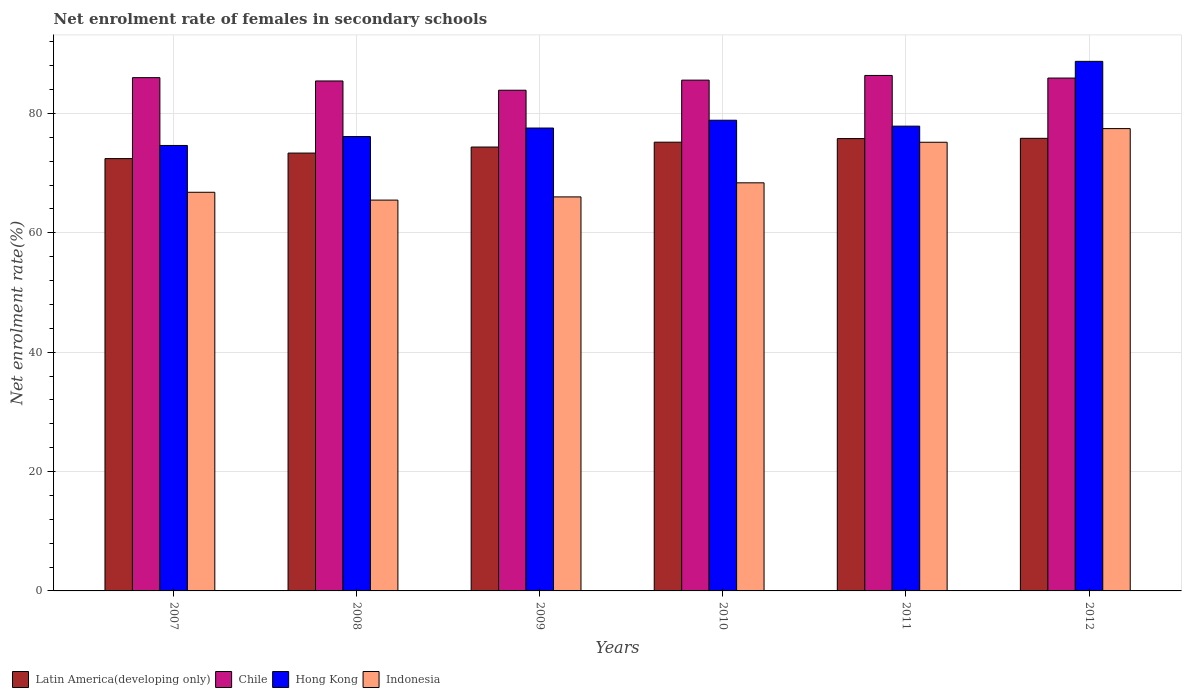How many different coloured bars are there?
Offer a very short reply. 4. Are the number of bars per tick equal to the number of legend labels?
Provide a succinct answer. Yes. How many bars are there on the 5th tick from the right?
Offer a very short reply. 4. What is the label of the 6th group of bars from the left?
Keep it short and to the point. 2012. In how many cases, is the number of bars for a given year not equal to the number of legend labels?
Offer a very short reply. 0. What is the net enrolment rate of females in secondary schools in Indonesia in 2012?
Your response must be concise. 77.46. Across all years, what is the maximum net enrolment rate of females in secondary schools in Hong Kong?
Your answer should be compact. 88.73. Across all years, what is the minimum net enrolment rate of females in secondary schools in Indonesia?
Ensure brevity in your answer.  65.48. In which year was the net enrolment rate of females in secondary schools in Chile maximum?
Keep it short and to the point. 2011. What is the total net enrolment rate of females in secondary schools in Latin America(developing only) in the graph?
Provide a succinct answer. 446.98. What is the difference between the net enrolment rate of females in secondary schools in Chile in 2007 and that in 2009?
Your response must be concise. 2.11. What is the difference between the net enrolment rate of females in secondary schools in Hong Kong in 2008 and the net enrolment rate of females in secondary schools in Latin America(developing only) in 2012?
Provide a succinct answer. 0.3. What is the average net enrolment rate of females in secondary schools in Indonesia per year?
Offer a terse response. 69.88. In the year 2012, what is the difference between the net enrolment rate of females in secondary schools in Latin America(developing only) and net enrolment rate of females in secondary schools in Chile?
Your answer should be compact. -10.1. In how many years, is the net enrolment rate of females in secondary schools in Hong Kong greater than 64 %?
Provide a succinct answer. 6. What is the ratio of the net enrolment rate of females in secondary schools in Chile in 2007 to that in 2012?
Your answer should be compact. 1. Is the net enrolment rate of females in secondary schools in Chile in 2007 less than that in 2008?
Ensure brevity in your answer.  No. Is the difference between the net enrolment rate of females in secondary schools in Latin America(developing only) in 2008 and 2010 greater than the difference between the net enrolment rate of females in secondary schools in Chile in 2008 and 2010?
Your response must be concise. No. What is the difference between the highest and the second highest net enrolment rate of females in secondary schools in Hong Kong?
Offer a terse response. 9.86. What is the difference between the highest and the lowest net enrolment rate of females in secondary schools in Indonesia?
Your response must be concise. 11.98. In how many years, is the net enrolment rate of females in secondary schools in Latin America(developing only) greater than the average net enrolment rate of females in secondary schools in Latin America(developing only) taken over all years?
Offer a terse response. 3. Is it the case that in every year, the sum of the net enrolment rate of females in secondary schools in Chile and net enrolment rate of females in secondary schools in Latin America(developing only) is greater than the sum of net enrolment rate of females in secondary schools in Indonesia and net enrolment rate of females in secondary schools in Hong Kong?
Offer a terse response. No. What does the 1st bar from the left in 2007 represents?
Your response must be concise. Latin America(developing only). What does the 3rd bar from the right in 2012 represents?
Provide a succinct answer. Chile. Is it the case that in every year, the sum of the net enrolment rate of females in secondary schools in Hong Kong and net enrolment rate of females in secondary schools in Indonesia is greater than the net enrolment rate of females in secondary schools in Latin America(developing only)?
Your answer should be very brief. Yes. What is the difference between two consecutive major ticks on the Y-axis?
Ensure brevity in your answer.  20. Where does the legend appear in the graph?
Your answer should be compact. Bottom left. How are the legend labels stacked?
Give a very brief answer. Horizontal. What is the title of the graph?
Give a very brief answer. Net enrolment rate of females in secondary schools. What is the label or title of the X-axis?
Your answer should be compact. Years. What is the label or title of the Y-axis?
Your answer should be very brief. Net enrolment rate(%). What is the Net enrolment rate(%) of Latin America(developing only) in 2007?
Provide a succinct answer. 72.44. What is the Net enrolment rate(%) in Chile in 2007?
Your response must be concise. 86. What is the Net enrolment rate(%) of Hong Kong in 2007?
Ensure brevity in your answer.  74.64. What is the Net enrolment rate(%) of Indonesia in 2007?
Give a very brief answer. 66.79. What is the Net enrolment rate(%) of Latin America(developing only) in 2008?
Make the answer very short. 73.36. What is the Net enrolment rate(%) of Chile in 2008?
Provide a succinct answer. 85.44. What is the Net enrolment rate(%) in Hong Kong in 2008?
Make the answer very short. 76.13. What is the Net enrolment rate(%) in Indonesia in 2008?
Provide a short and direct response. 65.48. What is the Net enrolment rate(%) in Latin America(developing only) in 2009?
Your answer should be very brief. 74.37. What is the Net enrolment rate(%) in Chile in 2009?
Offer a terse response. 83.89. What is the Net enrolment rate(%) in Hong Kong in 2009?
Your answer should be very brief. 77.56. What is the Net enrolment rate(%) of Indonesia in 2009?
Your response must be concise. 66.02. What is the Net enrolment rate(%) of Latin America(developing only) in 2010?
Make the answer very short. 75.19. What is the Net enrolment rate(%) in Chile in 2010?
Keep it short and to the point. 85.58. What is the Net enrolment rate(%) of Hong Kong in 2010?
Make the answer very short. 78.86. What is the Net enrolment rate(%) of Indonesia in 2010?
Ensure brevity in your answer.  68.38. What is the Net enrolment rate(%) of Latin America(developing only) in 2011?
Ensure brevity in your answer.  75.79. What is the Net enrolment rate(%) of Chile in 2011?
Your answer should be compact. 86.37. What is the Net enrolment rate(%) in Hong Kong in 2011?
Your response must be concise. 77.87. What is the Net enrolment rate(%) of Indonesia in 2011?
Provide a succinct answer. 75.17. What is the Net enrolment rate(%) of Latin America(developing only) in 2012?
Offer a terse response. 75.83. What is the Net enrolment rate(%) of Chile in 2012?
Ensure brevity in your answer.  85.93. What is the Net enrolment rate(%) in Hong Kong in 2012?
Give a very brief answer. 88.73. What is the Net enrolment rate(%) of Indonesia in 2012?
Provide a succinct answer. 77.46. Across all years, what is the maximum Net enrolment rate(%) of Latin America(developing only)?
Offer a very short reply. 75.83. Across all years, what is the maximum Net enrolment rate(%) in Chile?
Keep it short and to the point. 86.37. Across all years, what is the maximum Net enrolment rate(%) in Hong Kong?
Your answer should be compact. 88.73. Across all years, what is the maximum Net enrolment rate(%) of Indonesia?
Give a very brief answer. 77.46. Across all years, what is the minimum Net enrolment rate(%) of Latin America(developing only)?
Make the answer very short. 72.44. Across all years, what is the minimum Net enrolment rate(%) in Chile?
Offer a terse response. 83.89. Across all years, what is the minimum Net enrolment rate(%) of Hong Kong?
Ensure brevity in your answer.  74.64. Across all years, what is the minimum Net enrolment rate(%) in Indonesia?
Make the answer very short. 65.48. What is the total Net enrolment rate(%) of Latin America(developing only) in the graph?
Provide a succinct answer. 446.98. What is the total Net enrolment rate(%) in Chile in the graph?
Offer a terse response. 513.21. What is the total Net enrolment rate(%) of Hong Kong in the graph?
Provide a short and direct response. 473.79. What is the total Net enrolment rate(%) of Indonesia in the graph?
Offer a terse response. 419.31. What is the difference between the Net enrolment rate(%) in Latin America(developing only) in 2007 and that in 2008?
Your response must be concise. -0.93. What is the difference between the Net enrolment rate(%) of Chile in 2007 and that in 2008?
Ensure brevity in your answer.  0.55. What is the difference between the Net enrolment rate(%) in Hong Kong in 2007 and that in 2008?
Offer a very short reply. -1.49. What is the difference between the Net enrolment rate(%) of Indonesia in 2007 and that in 2008?
Offer a terse response. 1.31. What is the difference between the Net enrolment rate(%) in Latin America(developing only) in 2007 and that in 2009?
Ensure brevity in your answer.  -1.94. What is the difference between the Net enrolment rate(%) of Chile in 2007 and that in 2009?
Offer a terse response. 2.11. What is the difference between the Net enrolment rate(%) in Hong Kong in 2007 and that in 2009?
Offer a very short reply. -2.92. What is the difference between the Net enrolment rate(%) in Indonesia in 2007 and that in 2009?
Offer a terse response. 0.78. What is the difference between the Net enrolment rate(%) of Latin America(developing only) in 2007 and that in 2010?
Your answer should be very brief. -2.75. What is the difference between the Net enrolment rate(%) of Chile in 2007 and that in 2010?
Make the answer very short. 0.41. What is the difference between the Net enrolment rate(%) of Hong Kong in 2007 and that in 2010?
Give a very brief answer. -4.23. What is the difference between the Net enrolment rate(%) in Indonesia in 2007 and that in 2010?
Offer a terse response. -1.58. What is the difference between the Net enrolment rate(%) of Latin America(developing only) in 2007 and that in 2011?
Your answer should be compact. -3.35. What is the difference between the Net enrolment rate(%) in Chile in 2007 and that in 2011?
Your answer should be very brief. -0.37. What is the difference between the Net enrolment rate(%) in Hong Kong in 2007 and that in 2011?
Give a very brief answer. -3.23. What is the difference between the Net enrolment rate(%) in Indonesia in 2007 and that in 2011?
Your response must be concise. -8.38. What is the difference between the Net enrolment rate(%) in Latin America(developing only) in 2007 and that in 2012?
Offer a very short reply. -3.4. What is the difference between the Net enrolment rate(%) of Chile in 2007 and that in 2012?
Make the answer very short. 0.07. What is the difference between the Net enrolment rate(%) of Hong Kong in 2007 and that in 2012?
Provide a succinct answer. -14.09. What is the difference between the Net enrolment rate(%) in Indonesia in 2007 and that in 2012?
Offer a very short reply. -10.67. What is the difference between the Net enrolment rate(%) of Latin America(developing only) in 2008 and that in 2009?
Give a very brief answer. -1.01. What is the difference between the Net enrolment rate(%) in Chile in 2008 and that in 2009?
Provide a succinct answer. 1.55. What is the difference between the Net enrolment rate(%) in Hong Kong in 2008 and that in 2009?
Offer a very short reply. -1.43. What is the difference between the Net enrolment rate(%) of Indonesia in 2008 and that in 2009?
Ensure brevity in your answer.  -0.54. What is the difference between the Net enrolment rate(%) in Latin America(developing only) in 2008 and that in 2010?
Your answer should be very brief. -1.83. What is the difference between the Net enrolment rate(%) of Chile in 2008 and that in 2010?
Provide a succinct answer. -0.14. What is the difference between the Net enrolment rate(%) of Hong Kong in 2008 and that in 2010?
Provide a succinct answer. -2.73. What is the difference between the Net enrolment rate(%) of Indonesia in 2008 and that in 2010?
Your answer should be compact. -2.9. What is the difference between the Net enrolment rate(%) in Latin America(developing only) in 2008 and that in 2011?
Provide a short and direct response. -2.43. What is the difference between the Net enrolment rate(%) of Chile in 2008 and that in 2011?
Keep it short and to the point. -0.92. What is the difference between the Net enrolment rate(%) in Hong Kong in 2008 and that in 2011?
Your answer should be very brief. -1.74. What is the difference between the Net enrolment rate(%) in Indonesia in 2008 and that in 2011?
Give a very brief answer. -9.69. What is the difference between the Net enrolment rate(%) in Latin America(developing only) in 2008 and that in 2012?
Offer a very short reply. -2.47. What is the difference between the Net enrolment rate(%) of Chile in 2008 and that in 2012?
Your answer should be very brief. -0.49. What is the difference between the Net enrolment rate(%) of Hong Kong in 2008 and that in 2012?
Ensure brevity in your answer.  -12.6. What is the difference between the Net enrolment rate(%) of Indonesia in 2008 and that in 2012?
Provide a succinct answer. -11.98. What is the difference between the Net enrolment rate(%) of Latin America(developing only) in 2009 and that in 2010?
Keep it short and to the point. -0.82. What is the difference between the Net enrolment rate(%) of Chile in 2009 and that in 2010?
Keep it short and to the point. -1.69. What is the difference between the Net enrolment rate(%) of Hong Kong in 2009 and that in 2010?
Provide a short and direct response. -1.31. What is the difference between the Net enrolment rate(%) in Indonesia in 2009 and that in 2010?
Provide a succinct answer. -2.36. What is the difference between the Net enrolment rate(%) of Latin America(developing only) in 2009 and that in 2011?
Ensure brevity in your answer.  -1.42. What is the difference between the Net enrolment rate(%) in Chile in 2009 and that in 2011?
Provide a short and direct response. -2.48. What is the difference between the Net enrolment rate(%) in Hong Kong in 2009 and that in 2011?
Keep it short and to the point. -0.31. What is the difference between the Net enrolment rate(%) in Indonesia in 2009 and that in 2011?
Keep it short and to the point. -9.15. What is the difference between the Net enrolment rate(%) of Latin America(developing only) in 2009 and that in 2012?
Offer a very short reply. -1.46. What is the difference between the Net enrolment rate(%) in Chile in 2009 and that in 2012?
Keep it short and to the point. -2.04. What is the difference between the Net enrolment rate(%) in Hong Kong in 2009 and that in 2012?
Offer a terse response. -11.17. What is the difference between the Net enrolment rate(%) of Indonesia in 2009 and that in 2012?
Your answer should be compact. -11.44. What is the difference between the Net enrolment rate(%) of Latin America(developing only) in 2010 and that in 2011?
Make the answer very short. -0.6. What is the difference between the Net enrolment rate(%) of Chile in 2010 and that in 2011?
Keep it short and to the point. -0.78. What is the difference between the Net enrolment rate(%) in Indonesia in 2010 and that in 2011?
Your answer should be compact. -6.8. What is the difference between the Net enrolment rate(%) of Latin America(developing only) in 2010 and that in 2012?
Offer a very short reply. -0.65. What is the difference between the Net enrolment rate(%) of Chile in 2010 and that in 2012?
Offer a terse response. -0.35. What is the difference between the Net enrolment rate(%) of Hong Kong in 2010 and that in 2012?
Give a very brief answer. -9.87. What is the difference between the Net enrolment rate(%) of Indonesia in 2010 and that in 2012?
Your response must be concise. -9.09. What is the difference between the Net enrolment rate(%) of Latin America(developing only) in 2011 and that in 2012?
Your answer should be compact. -0.04. What is the difference between the Net enrolment rate(%) of Chile in 2011 and that in 2012?
Offer a very short reply. 0.44. What is the difference between the Net enrolment rate(%) of Hong Kong in 2011 and that in 2012?
Give a very brief answer. -10.86. What is the difference between the Net enrolment rate(%) of Indonesia in 2011 and that in 2012?
Make the answer very short. -2.29. What is the difference between the Net enrolment rate(%) in Latin America(developing only) in 2007 and the Net enrolment rate(%) in Chile in 2008?
Keep it short and to the point. -13.01. What is the difference between the Net enrolment rate(%) of Latin America(developing only) in 2007 and the Net enrolment rate(%) of Hong Kong in 2008?
Keep it short and to the point. -3.69. What is the difference between the Net enrolment rate(%) of Latin America(developing only) in 2007 and the Net enrolment rate(%) of Indonesia in 2008?
Your response must be concise. 6.95. What is the difference between the Net enrolment rate(%) in Chile in 2007 and the Net enrolment rate(%) in Hong Kong in 2008?
Keep it short and to the point. 9.87. What is the difference between the Net enrolment rate(%) in Chile in 2007 and the Net enrolment rate(%) in Indonesia in 2008?
Offer a very short reply. 20.52. What is the difference between the Net enrolment rate(%) in Hong Kong in 2007 and the Net enrolment rate(%) in Indonesia in 2008?
Keep it short and to the point. 9.16. What is the difference between the Net enrolment rate(%) of Latin America(developing only) in 2007 and the Net enrolment rate(%) of Chile in 2009?
Give a very brief answer. -11.46. What is the difference between the Net enrolment rate(%) of Latin America(developing only) in 2007 and the Net enrolment rate(%) of Hong Kong in 2009?
Keep it short and to the point. -5.12. What is the difference between the Net enrolment rate(%) in Latin America(developing only) in 2007 and the Net enrolment rate(%) in Indonesia in 2009?
Offer a very short reply. 6.42. What is the difference between the Net enrolment rate(%) in Chile in 2007 and the Net enrolment rate(%) in Hong Kong in 2009?
Make the answer very short. 8.44. What is the difference between the Net enrolment rate(%) in Chile in 2007 and the Net enrolment rate(%) in Indonesia in 2009?
Provide a short and direct response. 19.98. What is the difference between the Net enrolment rate(%) in Hong Kong in 2007 and the Net enrolment rate(%) in Indonesia in 2009?
Offer a very short reply. 8.62. What is the difference between the Net enrolment rate(%) of Latin America(developing only) in 2007 and the Net enrolment rate(%) of Chile in 2010?
Ensure brevity in your answer.  -13.15. What is the difference between the Net enrolment rate(%) in Latin America(developing only) in 2007 and the Net enrolment rate(%) in Hong Kong in 2010?
Give a very brief answer. -6.43. What is the difference between the Net enrolment rate(%) of Latin America(developing only) in 2007 and the Net enrolment rate(%) of Indonesia in 2010?
Offer a very short reply. 4.06. What is the difference between the Net enrolment rate(%) of Chile in 2007 and the Net enrolment rate(%) of Hong Kong in 2010?
Provide a succinct answer. 7.13. What is the difference between the Net enrolment rate(%) in Chile in 2007 and the Net enrolment rate(%) in Indonesia in 2010?
Keep it short and to the point. 17.62. What is the difference between the Net enrolment rate(%) of Hong Kong in 2007 and the Net enrolment rate(%) of Indonesia in 2010?
Your answer should be very brief. 6.26. What is the difference between the Net enrolment rate(%) of Latin America(developing only) in 2007 and the Net enrolment rate(%) of Chile in 2011?
Your response must be concise. -13.93. What is the difference between the Net enrolment rate(%) of Latin America(developing only) in 2007 and the Net enrolment rate(%) of Hong Kong in 2011?
Offer a terse response. -5.44. What is the difference between the Net enrolment rate(%) in Latin America(developing only) in 2007 and the Net enrolment rate(%) in Indonesia in 2011?
Provide a short and direct response. -2.74. What is the difference between the Net enrolment rate(%) of Chile in 2007 and the Net enrolment rate(%) of Hong Kong in 2011?
Provide a short and direct response. 8.13. What is the difference between the Net enrolment rate(%) in Chile in 2007 and the Net enrolment rate(%) in Indonesia in 2011?
Ensure brevity in your answer.  10.83. What is the difference between the Net enrolment rate(%) in Hong Kong in 2007 and the Net enrolment rate(%) in Indonesia in 2011?
Offer a terse response. -0.54. What is the difference between the Net enrolment rate(%) of Latin America(developing only) in 2007 and the Net enrolment rate(%) of Chile in 2012?
Make the answer very short. -13.5. What is the difference between the Net enrolment rate(%) in Latin America(developing only) in 2007 and the Net enrolment rate(%) in Hong Kong in 2012?
Make the answer very short. -16.29. What is the difference between the Net enrolment rate(%) in Latin America(developing only) in 2007 and the Net enrolment rate(%) in Indonesia in 2012?
Keep it short and to the point. -5.03. What is the difference between the Net enrolment rate(%) in Chile in 2007 and the Net enrolment rate(%) in Hong Kong in 2012?
Provide a short and direct response. -2.73. What is the difference between the Net enrolment rate(%) in Chile in 2007 and the Net enrolment rate(%) in Indonesia in 2012?
Make the answer very short. 8.54. What is the difference between the Net enrolment rate(%) in Hong Kong in 2007 and the Net enrolment rate(%) in Indonesia in 2012?
Provide a succinct answer. -2.83. What is the difference between the Net enrolment rate(%) of Latin America(developing only) in 2008 and the Net enrolment rate(%) of Chile in 2009?
Offer a very short reply. -10.53. What is the difference between the Net enrolment rate(%) in Latin America(developing only) in 2008 and the Net enrolment rate(%) in Hong Kong in 2009?
Offer a terse response. -4.2. What is the difference between the Net enrolment rate(%) in Latin America(developing only) in 2008 and the Net enrolment rate(%) in Indonesia in 2009?
Provide a short and direct response. 7.34. What is the difference between the Net enrolment rate(%) in Chile in 2008 and the Net enrolment rate(%) in Hong Kong in 2009?
Provide a succinct answer. 7.89. What is the difference between the Net enrolment rate(%) in Chile in 2008 and the Net enrolment rate(%) in Indonesia in 2009?
Give a very brief answer. 19.43. What is the difference between the Net enrolment rate(%) of Hong Kong in 2008 and the Net enrolment rate(%) of Indonesia in 2009?
Your answer should be very brief. 10.11. What is the difference between the Net enrolment rate(%) in Latin America(developing only) in 2008 and the Net enrolment rate(%) in Chile in 2010?
Your answer should be very brief. -12.22. What is the difference between the Net enrolment rate(%) of Latin America(developing only) in 2008 and the Net enrolment rate(%) of Hong Kong in 2010?
Offer a terse response. -5.5. What is the difference between the Net enrolment rate(%) of Latin America(developing only) in 2008 and the Net enrolment rate(%) of Indonesia in 2010?
Ensure brevity in your answer.  4.98. What is the difference between the Net enrolment rate(%) in Chile in 2008 and the Net enrolment rate(%) in Hong Kong in 2010?
Offer a very short reply. 6.58. What is the difference between the Net enrolment rate(%) of Chile in 2008 and the Net enrolment rate(%) of Indonesia in 2010?
Provide a succinct answer. 17.07. What is the difference between the Net enrolment rate(%) of Hong Kong in 2008 and the Net enrolment rate(%) of Indonesia in 2010?
Offer a terse response. 7.75. What is the difference between the Net enrolment rate(%) in Latin America(developing only) in 2008 and the Net enrolment rate(%) in Chile in 2011?
Offer a terse response. -13.01. What is the difference between the Net enrolment rate(%) in Latin America(developing only) in 2008 and the Net enrolment rate(%) in Hong Kong in 2011?
Ensure brevity in your answer.  -4.51. What is the difference between the Net enrolment rate(%) of Latin America(developing only) in 2008 and the Net enrolment rate(%) of Indonesia in 2011?
Keep it short and to the point. -1.81. What is the difference between the Net enrolment rate(%) of Chile in 2008 and the Net enrolment rate(%) of Hong Kong in 2011?
Offer a terse response. 7.57. What is the difference between the Net enrolment rate(%) in Chile in 2008 and the Net enrolment rate(%) in Indonesia in 2011?
Give a very brief answer. 10.27. What is the difference between the Net enrolment rate(%) in Hong Kong in 2008 and the Net enrolment rate(%) in Indonesia in 2011?
Your answer should be compact. 0.96. What is the difference between the Net enrolment rate(%) in Latin America(developing only) in 2008 and the Net enrolment rate(%) in Chile in 2012?
Ensure brevity in your answer.  -12.57. What is the difference between the Net enrolment rate(%) in Latin America(developing only) in 2008 and the Net enrolment rate(%) in Hong Kong in 2012?
Your response must be concise. -15.37. What is the difference between the Net enrolment rate(%) of Latin America(developing only) in 2008 and the Net enrolment rate(%) of Indonesia in 2012?
Your answer should be compact. -4.1. What is the difference between the Net enrolment rate(%) in Chile in 2008 and the Net enrolment rate(%) in Hong Kong in 2012?
Provide a succinct answer. -3.28. What is the difference between the Net enrolment rate(%) in Chile in 2008 and the Net enrolment rate(%) in Indonesia in 2012?
Offer a terse response. 7.98. What is the difference between the Net enrolment rate(%) in Hong Kong in 2008 and the Net enrolment rate(%) in Indonesia in 2012?
Your response must be concise. -1.33. What is the difference between the Net enrolment rate(%) of Latin America(developing only) in 2009 and the Net enrolment rate(%) of Chile in 2010?
Your response must be concise. -11.21. What is the difference between the Net enrolment rate(%) of Latin America(developing only) in 2009 and the Net enrolment rate(%) of Hong Kong in 2010?
Your answer should be very brief. -4.49. What is the difference between the Net enrolment rate(%) of Latin America(developing only) in 2009 and the Net enrolment rate(%) of Indonesia in 2010?
Provide a succinct answer. 5.99. What is the difference between the Net enrolment rate(%) of Chile in 2009 and the Net enrolment rate(%) of Hong Kong in 2010?
Your response must be concise. 5.03. What is the difference between the Net enrolment rate(%) of Chile in 2009 and the Net enrolment rate(%) of Indonesia in 2010?
Provide a short and direct response. 15.51. What is the difference between the Net enrolment rate(%) of Hong Kong in 2009 and the Net enrolment rate(%) of Indonesia in 2010?
Offer a terse response. 9.18. What is the difference between the Net enrolment rate(%) in Latin America(developing only) in 2009 and the Net enrolment rate(%) in Chile in 2011?
Keep it short and to the point. -12. What is the difference between the Net enrolment rate(%) in Latin America(developing only) in 2009 and the Net enrolment rate(%) in Hong Kong in 2011?
Your answer should be very brief. -3.5. What is the difference between the Net enrolment rate(%) of Latin America(developing only) in 2009 and the Net enrolment rate(%) of Indonesia in 2011?
Keep it short and to the point. -0.8. What is the difference between the Net enrolment rate(%) of Chile in 2009 and the Net enrolment rate(%) of Hong Kong in 2011?
Provide a short and direct response. 6.02. What is the difference between the Net enrolment rate(%) in Chile in 2009 and the Net enrolment rate(%) in Indonesia in 2011?
Your response must be concise. 8.72. What is the difference between the Net enrolment rate(%) in Hong Kong in 2009 and the Net enrolment rate(%) in Indonesia in 2011?
Keep it short and to the point. 2.38. What is the difference between the Net enrolment rate(%) in Latin America(developing only) in 2009 and the Net enrolment rate(%) in Chile in 2012?
Keep it short and to the point. -11.56. What is the difference between the Net enrolment rate(%) of Latin America(developing only) in 2009 and the Net enrolment rate(%) of Hong Kong in 2012?
Make the answer very short. -14.36. What is the difference between the Net enrolment rate(%) of Latin America(developing only) in 2009 and the Net enrolment rate(%) of Indonesia in 2012?
Your answer should be compact. -3.09. What is the difference between the Net enrolment rate(%) in Chile in 2009 and the Net enrolment rate(%) in Hong Kong in 2012?
Offer a terse response. -4.84. What is the difference between the Net enrolment rate(%) of Chile in 2009 and the Net enrolment rate(%) of Indonesia in 2012?
Provide a succinct answer. 6.43. What is the difference between the Net enrolment rate(%) of Hong Kong in 2009 and the Net enrolment rate(%) of Indonesia in 2012?
Your response must be concise. 0.09. What is the difference between the Net enrolment rate(%) in Latin America(developing only) in 2010 and the Net enrolment rate(%) in Chile in 2011?
Give a very brief answer. -11.18. What is the difference between the Net enrolment rate(%) in Latin America(developing only) in 2010 and the Net enrolment rate(%) in Hong Kong in 2011?
Provide a succinct answer. -2.68. What is the difference between the Net enrolment rate(%) of Latin America(developing only) in 2010 and the Net enrolment rate(%) of Indonesia in 2011?
Ensure brevity in your answer.  0.02. What is the difference between the Net enrolment rate(%) of Chile in 2010 and the Net enrolment rate(%) of Hong Kong in 2011?
Provide a succinct answer. 7.71. What is the difference between the Net enrolment rate(%) in Chile in 2010 and the Net enrolment rate(%) in Indonesia in 2011?
Ensure brevity in your answer.  10.41. What is the difference between the Net enrolment rate(%) in Hong Kong in 2010 and the Net enrolment rate(%) in Indonesia in 2011?
Offer a very short reply. 3.69. What is the difference between the Net enrolment rate(%) in Latin America(developing only) in 2010 and the Net enrolment rate(%) in Chile in 2012?
Keep it short and to the point. -10.74. What is the difference between the Net enrolment rate(%) in Latin America(developing only) in 2010 and the Net enrolment rate(%) in Hong Kong in 2012?
Provide a succinct answer. -13.54. What is the difference between the Net enrolment rate(%) in Latin America(developing only) in 2010 and the Net enrolment rate(%) in Indonesia in 2012?
Keep it short and to the point. -2.27. What is the difference between the Net enrolment rate(%) in Chile in 2010 and the Net enrolment rate(%) in Hong Kong in 2012?
Offer a terse response. -3.15. What is the difference between the Net enrolment rate(%) in Chile in 2010 and the Net enrolment rate(%) in Indonesia in 2012?
Ensure brevity in your answer.  8.12. What is the difference between the Net enrolment rate(%) in Hong Kong in 2010 and the Net enrolment rate(%) in Indonesia in 2012?
Offer a terse response. 1.4. What is the difference between the Net enrolment rate(%) of Latin America(developing only) in 2011 and the Net enrolment rate(%) of Chile in 2012?
Make the answer very short. -10.14. What is the difference between the Net enrolment rate(%) in Latin America(developing only) in 2011 and the Net enrolment rate(%) in Hong Kong in 2012?
Your response must be concise. -12.94. What is the difference between the Net enrolment rate(%) in Latin America(developing only) in 2011 and the Net enrolment rate(%) in Indonesia in 2012?
Offer a very short reply. -1.67. What is the difference between the Net enrolment rate(%) of Chile in 2011 and the Net enrolment rate(%) of Hong Kong in 2012?
Your response must be concise. -2.36. What is the difference between the Net enrolment rate(%) of Chile in 2011 and the Net enrolment rate(%) of Indonesia in 2012?
Make the answer very short. 8.9. What is the difference between the Net enrolment rate(%) of Hong Kong in 2011 and the Net enrolment rate(%) of Indonesia in 2012?
Keep it short and to the point. 0.41. What is the average Net enrolment rate(%) of Latin America(developing only) per year?
Ensure brevity in your answer.  74.5. What is the average Net enrolment rate(%) of Chile per year?
Your response must be concise. 85.54. What is the average Net enrolment rate(%) in Hong Kong per year?
Offer a very short reply. 78.96. What is the average Net enrolment rate(%) in Indonesia per year?
Make the answer very short. 69.88. In the year 2007, what is the difference between the Net enrolment rate(%) in Latin America(developing only) and Net enrolment rate(%) in Chile?
Your answer should be compact. -13.56. In the year 2007, what is the difference between the Net enrolment rate(%) of Latin America(developing only) and Net enrolment rate(%) of Hong Kong?
Make the answer very short. -2.2. In the year 2007, what is the difference between the Net enrolment rate(%) in Latin America(developing only) and Net enrolment rate(%) in Indonesia?
Give a very brief answer. 5.64. In the year 2007, what is the difference between the Net enrolment rate(%) of Chile and Net enrolment rate(%) of Hong Kong?
Give a very brief answer. 11.36. In the year 2007, what is the difference between the Net enrolment rate(%) in Chile and Net enrolment rate(%) in Indonesia?
Your answer should be compact. 19.2. In the year 2007, what is the difference between the Net enrolment rate(%) of Hong Kong and Net enrolment rate(%) of Indonesia?
Keep it short and to the point. 7.84. In the year 2008, what is the difference between the Net enrolment rate(%) of Latin America(developing only) and Net enrolment rate(%) of Chile?
Your answer should be compact. -12.08. In the year 2008, what is the difference between the Net enrolment rate(%) of Latin America(developing only) and Net enrolment rate(%) of Hong Kong?
Ensure brevity in your answer.  -2.77. In the year 2008, what is the difference between the Net enrolment rate(%) of Latin America(developing only) and Net enrolment rate(%) of Indonesia?
Offer a very short reply. 7.88. In the year 2008, what is the difference between the Net enrolment rate(%) of Chile and Net enrolment rate(%) of Hong Kong?
Keep it short and to the point. 9.31. In the year 2008, what is the difference between the Net enrolment rate(%) of Chile and Net enrolment rate(%) of Indonesia?
Ensure brevity in your answer.  19.96. In the year 2008, what is the difference between the Net enrolment rate(%) of Hong Kong and Net enrolment rate(%) of Indonesia?
Your answer should be compact. 10.65. In the year 2009, what is the difference between the Net enrolment rate(%) in Latin America(developing only) and Net enrolment rate(%) in Chile?
Provide a succinct answer. -9.52. In the year 2009, what is the difference between the Net enrolment rate(%) in Latin America(developing only) and Net enrolment rate(%) in Hong Kong?
Ensure brevity in your answer.  -3.19. In the year 2009, what is the difference between the Net enrolment rate(%) in Latin America(developing only) and Net enrolment rate(%) in Indonesia?
Offer a very short reply. 8.35. In the year 2009, what is the difference between the Net enrolment rate(%) of Chile and Net enrolment rate(%) of Hong Kong?
Offer a very short reply. 6.33. In the year 2009, what is the difference between the Net enrolment rate(%) of Chile and Net enrolment rate(%) of Indonesia?
Your response must be concise. 17.87. In the year 2009, what is the difference between the Net enrolment rate(%) in Hong Kong and Net enrolment rate(%) in Indonesia?
Ensure brevity in your answer.  11.54. In the year 2010, what is the difference between the Net enrolment rate(%) of Latin America(developing only) and Net enrolment rate(%) of Chile?
Your answer should be very brief. -10.4. In the year 2010, what is the difference between the Net enrolment rate(%) in Latin America(developing only) and Net enrolment rate(%) in Hong Kong?
Your answer should be compact. -3.68. In the year 2010, what is the difference between the Net enrolment rate(%) of Latin America(developing only) and Net enrolment rate(%) of Indonesia?
Make the answer very short. 6.81. In the year 2010, what is the difference between the Net enrolment rate(%) of Chile and Net enrolment rate(%) of Hong Kong?
Your answer should be very brief. 6.72. In the year 2010, what is the difference between the Net enrolment rate(%) of Chile and Net enrolment rate(%) of Indonesia?
Provide a succinct answer. 17.21. In the year 2010, what is the difference between the Net enrolment rate(%) in Hong Kong and Net enrolment rate(%) in Indonesia?
Offer a terse response. 10.49. In the year 2011, what is the difference between the Net enrolment rate(%) in Latin America(developing only) and Net enrolment rate(%) in Chile?
Provide a short and direct response. -10.58. In the year 2011, what is the difference between the Net enrolment rate(%) in Latin America(developing only) and Net enrolment rate(%) in Hong Kong?
Your answer should be very brief. -2.08. In the year 2011, what is the difference between the Net enrolment rate(%) of Latin America(developing only) and Net enrolment rate(%) of Indonesia?
Provide a short and direct response. 0.62. In the year 2011, what is the difference between the Net enrolment rate(%) in Chile and Net enrolment rate(%) in Hong Kong?
Ensure brevity in your answer.  8.5. In the year 2011, what is the difference between the Net enrolment rate(%) of Chile and Net enrolment rate(%) of Indonesia?
Ensure brevity in your answer.  11.2. In the year 2011, what is the difference between the Net enrolment rate(%) of Hong Kong and Net enrolment rate(%) of Indonesia?
Provide a succinct answer. 2.7. In the year 2012, what is the difference between the Net enrolment rate(%) of Latin America(developing only) and Net enrolment rate(%) of Chile?
Provide a succinct answer. -10.1. In the year 2012, what is the difference between the Net enrolment rate(%) in Latin America(developing only) and Net enrolment rate(%) in Hong Kong?
Keep it short and to the point. -12.9. In the year 2012, what is the difference between the Net enrolment rate(%) in Latin America(developing only) and Net enrolment rate(%) in Indonesia?
Provide a short and direct response. -1.63. In the year 2012, what is the difference between the Net enrolment rate(%) in Chile and Net enrolment rate(%) in Hong Kong?
Ensure brevity in your answer.  -2.8. In the year 2012, what is the difference between the Net enrolment rate(%) in Chile and Net enrolment rate(%) in Indonesia?
Keep it short and to the point. 8.47. In the year 2012, what is the difference between the Net enrolment rate(%) in Hong Kong and Net enrolment rate(%) in Indonesia?
Ensure brevity in your answer.  11.27. What is the ratio of the Net enrolment rate(%) of Latin America(developing only) in 2007 to that in 2008?
Your answer should be compact. 0.99. What is the ratio of the Net enrolment rate(%) in Chile in 2007 to that in 2008?
Provide a short and direct response. 1.01. What is the ratio of the Net enrolment rate(%) of Hong Kong in 2007 to that in 2008?
Give a very brief answer. 0.98. What is the ratio of the Net enrolment rate(%) in Indonesia in 2007 to that in 2008?
Offer a terse response. 1.02. What is the ratio of the Net enrolment rate(%) of Chile in 2007 to that in 2009?
Your answer should be compact. 1.03. What is the ratio of the Net enrolment rate(%) of Hong Kong in 2007 to that in 2009?
Give a very brief answer. 0.96. What is the ratio of the Net enrolment rate(%) of Indonesia in 2007 to that in 2009?
Your answer should be compact. 1.01. What is the ratio of the Net enrolment rate(%) in Latin America(developing only) in 2007 to that in 2010?
Keep it short and to the point. 0.96. What is the ratio of the Net enrolment rate(%) in Hong Kong in 2007 to that in 2010?
Your answer should be very brief. 0.95. What is the ratio of the Net enrolment rate(%) of Indonesia in 2007 to that in 2010?
Your answer should be compact. 0.98. What is the ratio of the Net enrolment rate(%) of Latin America(developing only) in 2007 to that in 2011?
Your answer should be compact. 0.96. What is the ratio of the Net enrolment rate(%) of Hong Kong in 2007 to that in 2011?
Your answer should be very brief. 0.96. What is the ratio of the Net enrolment rate(%) of Indonesia in 2007 to that in 2011?
Make the answer very short. 0.89. What is the ratio of the Net enrolment rate(%) in Latin America(developing only) in 2007 to that in 2012?
Your answer should be compact. 0.96. What is the ratio of the Net enrolment rate(%) in Chile in 2007 to that in 2012?
Give a very brief answer. 1. What is the ratio of the Net enrolment rate(%) in Hong Kong in 2007 to that in 2012?
Your response must be concise. 0.84. What is the ratio of the Net enrolment rate(%) in Indonesia in 2007 to that in 2012?
Provide a succinct answer. 0.86. What is the ratio of the Net enrolment rate(%) of Latin America(developing only) in 2008 to that in 2009?
Provide a short and direct response. 0.99. What is the ratio of the Net enrolment rate(%) of Chile in 2008 to that in 2009?
Provide a succinct answer. 1.02. What is the ratio of the Net enrolment rate(%) of Hong Kong in 2008 to that in 2009?
Provide a succinct answer. 0.98. What is the ratio of the Net enrolment rate(%) in Latin America(developing only) in 2008 to that in 2010?
Keep it short and to the point. 0.98. What is the ratio of the Net enrolment rate(%) of Hong Kong in 2008 to that in 2010?
Make the answer very short. 0.97. What is the ratio of the Net enrolment rate(%) of Indonesia in 2008 to that in 2010?
Offer a very short reply. 0.96. What is the ratio of the Net enrolment rate(%) of Chile in 2008 to that in 2011?
Provide a succinct answer. 0.99. What is the ratio of the Net enrolment rate(%) of Hong Kong in 2008 to that in 2011?
Provide a succinct answer. 0.98. What is the ratio of the Net enrolment rate(%) of Indonesia in 2008 to that in 2011?
Provide a succinct answer. 0.87. What is the ratio of the Net enrolment rate(%) of Latin America(developing only) in 2008 to that in 2012?
Provide a short and direct response. 0.97. What is the ratio of the Net enrolment rate(%) of Hong Kong in 2008 to that in 2012?
Your answer should be very brief. 0.86. What is the ratio of the Net enrolment rate(%) in Indonesia in 2008 to that in 2012?
Give a very brief answer. 0.85. What is the ratio of the Net enrolment rate(%) of Chile in 2009 to that in 2010?
Your answer should be compact. 0.98. What is the ratio of the Net enrolment rate(%) in Hong Kong in 2009 to that in 2010?
Make the answer very short. 0.98. What is the ratio of the Net enrolment rate(%) of Indonesia in 2009 to that in 2010?
Ensure brevity in your answer.  0.97. What is the ratio of the Net enrolment rate(%) in Latin America(developing only) in 2009 to that in 2011?
Give a very brief answer. 0.98. What is the ratio of the Net enrolment rate(%) in Chile in 2009 to that in 2011?
Offer a very short reply. 0.97. What is the ratio of the Net enrolment rate(%) in Hong Kong in 2009 to that in 2011?
Keep it short and to the point. 1. What is the ratio of the Net enrolment rate(%) of Indonesia in 2009 to that in 2011?
Offer a terse response. 0.88. What is the ratio of the Net enrolment rate(%) in Latin America(developing only) in 2009 to that in 2012?
Your response must be concise. 0.98. What is the ratio of the Net enrolment rate(%) of Chile in 2009 to that in 2012?
Make the answer very short. 0.98. What is the ratio of the Net enrolment rate(%) in Hong Kong in 2009 to that in 2012?
Ensure brevity in your answer.  0.87. What is the ratio of the Net enrolment rate(%) in Indonesia in 2009 to that in 2012?
Your answer should be compact. 0.85. What is the ratio of the Net enrolment rate(%) in Chile in 2010 to that in 2011?
Offer a terse response. 0.99. What is the ratio of the Net enrolment rate(%) in Hong Kong in 2010 to that in 2011?
Give a very brief answer. 1.01. What is the ratio of the Net enrolment rate(%) of Indonesia in 2010 to that in 2011?
Keep it short and to the point. 0.91. What is the ratio of the Net enrolment rate(%) of Latin America(developing only) in 2010 to that in 2012?
Give a very brief answer. 0.99. What is the ratio of the Net enrolment rate(%) of Hong Kong in 2010 to that in 2012?
Offer a terse response. 0.89. What is the ratio of the Net enrolment rate(%) in Indonesia in 2010 to that in 2012?
Provide a short and direct response. 0.88. What is the ratio of the Net enrolment rate(%) of Chile in 2011 to that in 2012?
Your answer should be very brief. 1.01. What is the ratio of the Net enrolment rate(%) of Hong Kong in 2011 to that in 2012?
Provide a short and direct response. 0.88. What is the ratio of the Net enrolment rate(%) in Indonesia in 2011 to that in 2012?
Provide a succinct answer. 0.97. What is the difference between the highest and the second highest Net enrolment rate(%) in Latin America(developing only)?
Offer a very short reply. 0.04. What is the difference between the highest and the second highest Net enrolment rate(%) of Chile?
Give a very brief answer. 0.37. What is the difference between the highest and the second highest Net enrolment rate(%) of Hong Kong?
Ensure brevity in your answer.  9.87. What is the difference between the highest and the second highest Net enrolment rate(%) in Indonesia?
Give a very brief answer. 2.29. What is the difference between the highest and the lowest Net enrolment rate(%) of Latin America(developing only)?
Provide a short and direct response. 3.4. What is the difference between the highest and the lowest Net enrolment rate(%) in Chile?
Your response must be concise. 2.48. What is the difference between the highest and the lowest Net enrolment rate(%) in Hong Kong?
Make the answer very short. 14.09. What is the difference between the highest and the lowest Net enrolment rate(%) in Indonesia?
Keep it short and to the point. 11.98. 